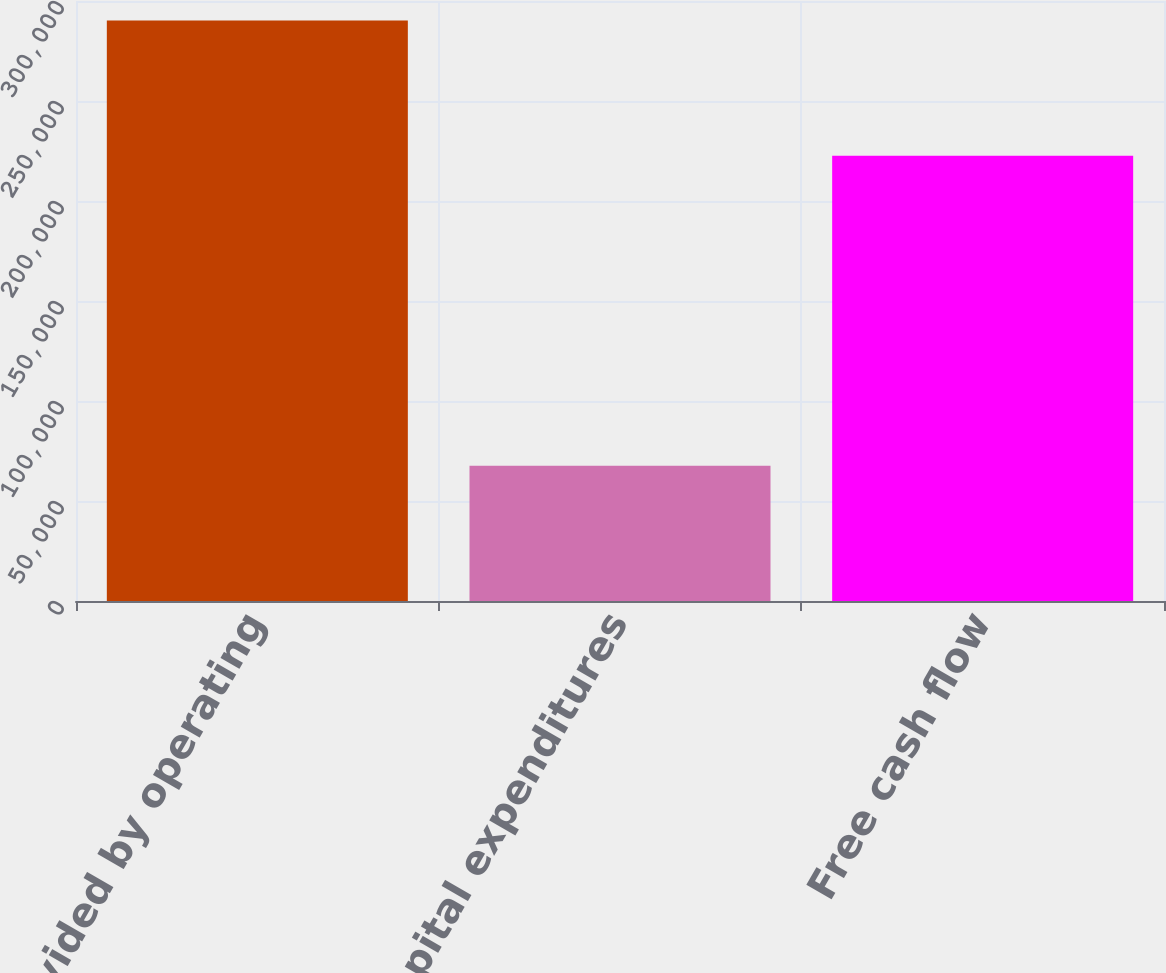Convert chart. <chart><loc_0><loc_0><loc_500><loc_500><bar_chart><fcel>Net cash provided by operating<fcel>Less Capital expenditures<fcel>Free cash flow<nl><fcel>290241<fcel>67571<fcel>222670<nl></chart> 